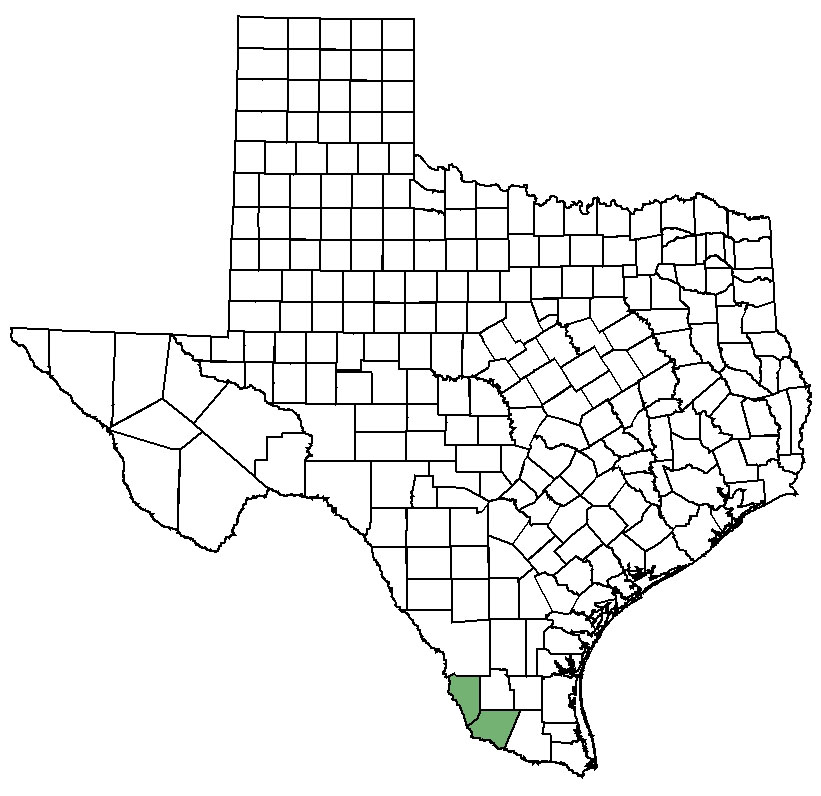Imagine the highlighted county is the setting for a futuristic sci-fi movie. What alien ecosystems might be discovered there? In a futuristic sci-fi movie, the highlighted county could be portrayed as a hub for alien ecosystems. Imagine vast fields where bioluminescent plants sway under twin suns, and rivers glow a brilliant blue with microorganisms that possess healing properties. The air is filled with the symphony of alien insects that communicate through harmonic frequencies, and towering cacti with sentient abilities observing intruders. Beneath the desert surface, vast underground cities of crystalline structures house the intelligent native species, who have a symbiotic relationship with the environment, maintaining its delicate balance. This imaginative ecosystem provides a visually stunning and thought-provoking backdrop for an engaging sci-fi narrative. 